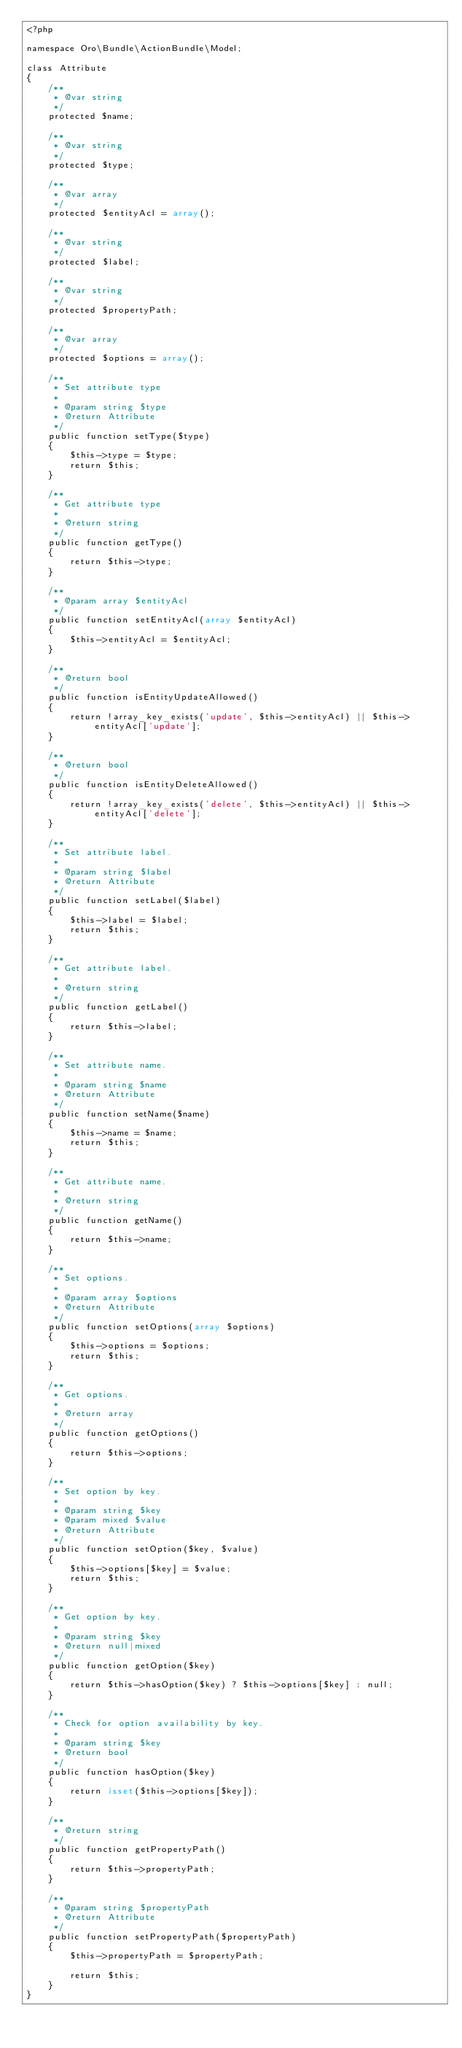<code> <loc_0><loc_0><loc_500><loc_500><_PHP_><?php

namespace Oro\Bundle\ActionBundle\Model;

class Attribute
{
    /**
     * @var string
     */
    protected $name;

    /**
     * @var string
     */
    protected $type;

    /**
     * @var array
     */
    protected $entityAcl = array();

    /**
     * @var string
     */
    protected $label;

    /**
     * @var string
     */
    protected $propertyPath;

    /**
     * @var array
     */
    protected $options = array();

    /**
     * Set attribute type
     *
     * @param string $type
     * @return Attribute
     */
    public function setType($type)
    {
        $this->type = $type;
        return $this;
    }

    /**
     * Get attribute type
     *
     * @return string
     */
    public function getType()
    {
        return $this->type;
    }

    /**
     * @param array $entityAcl
     */
    public function setEntityAcl(array $entityAcl)
    {
        $this->entityAcl = $entityAcl;
    }

    /**
     * @return bool
     */
    public function isEntityUpdateAllowed()
    {
        return !array_key_exists('update', $this->entityAcl) || $this->entityAcl['update'];
    }

    /**
     * @return bool
     */
    public function isEntityDeleteAllowed()
    {
        return !array_key_exists('delete', $this->entityAcl) || $this->entityAcl['delete'];
    }

    /**
     * Set attribute label.
     *
     * @param string $label
     * @return Attribute
     */
    public function setLabel($label)
    {
        $this->label = $label;
        return $this;
    }

    /**
     * Get attribute label.
     *
     * @return string
     */
    public function getLabel()
    {
        return $this->label;
    }

    /**
     * Set attribute name.
     *
     * @param string $name
     * @return Attribute
     */
    public function setName($name)
    {
        $this->name = $name;
        return $this;
    }

    /**
     * Get attribute name.
     *
     * @return string
     */
    public function getName()
    {
        return $this->name;
    }

    /**
     * Set options.
     *
     * @param array $options
     * @return Attribute
     */
    public function setOptions(array $options)
    {
        $this->options = $options;
        return $this;
    }

    /**
     * Get options.
     *
     * @return array
     */
    public function getOptions()
    {
        return $this->options;
    }

    /**
     * Set option by key.
     *
     * @param string $key
     * @param mixed $value
     * @return Attribute
     */
    public function setOption($key, $value)
    {
        $this->options[$key] = $value;
        return $this;
    }

    /**
     * Get option by key.
     *
     * @param string $key
     * @return null|mixed
     */
    public function getOption($key)
    {
        return $this->hasOption($key) ? $this->options[$key] : null;
    }

    /**
     * Check for option availability by key.
     *
     * @param string $key
     * @return bool
     */
    public function hasOption($key)
    {
        return isset($this->options[$key]);
    }

    /**
     * @return string
     */
    public function getPropertyPath()
    {
        return $this->propertyPath;
    }

    /**
     * @param string $propertyPath
     * @return Attribute
     */
    public function setPropertyPath($propertyPath)
    {
        $this->propertyPath = $propertyPath;

        return $this;
    }
}
</code> 